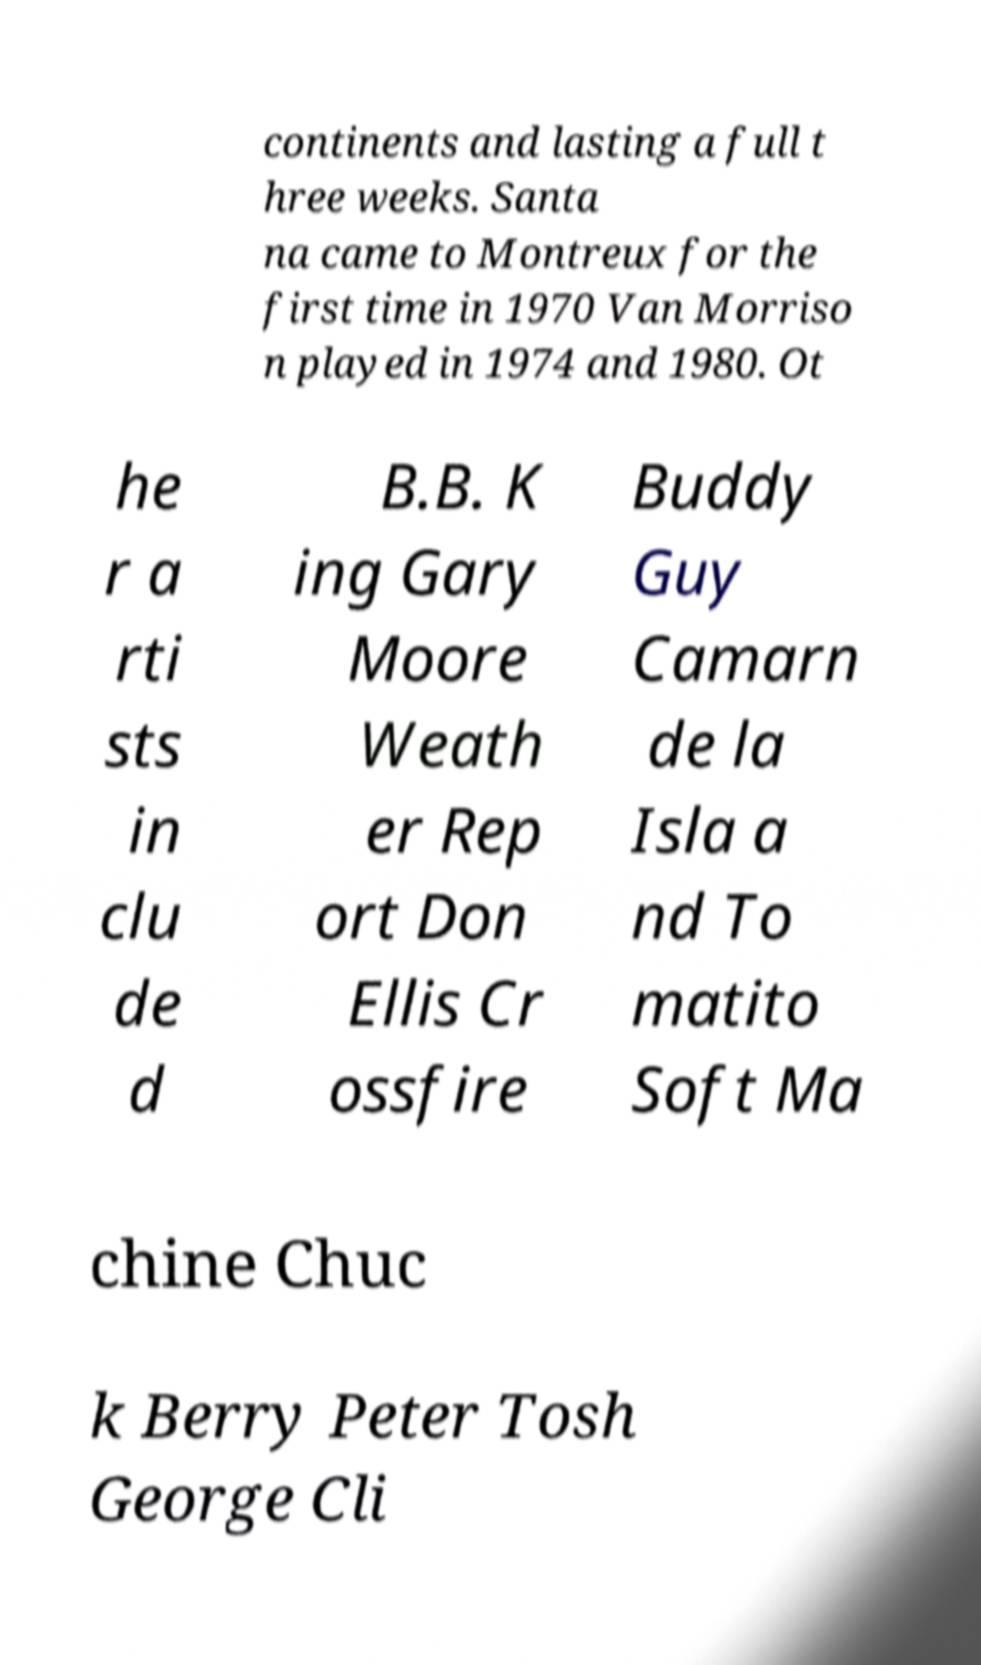There's text embedded in this image that I need extracted. Can you transcribe it verbatim? continents and lasting a full t hree weeks. Santa na came to Montreux for the first time in 1970 Van Morriso n played in 1974 and 1980. Ot he r a rti sts in clu de d B.B. K ing Gary Moore Weath er Rep ort Don Ellis Cr ossfire Buddy Guy Camarn de la Isla a nd To matito Soft Ma chine Chuc k Berry Peter Tosh George Cli 